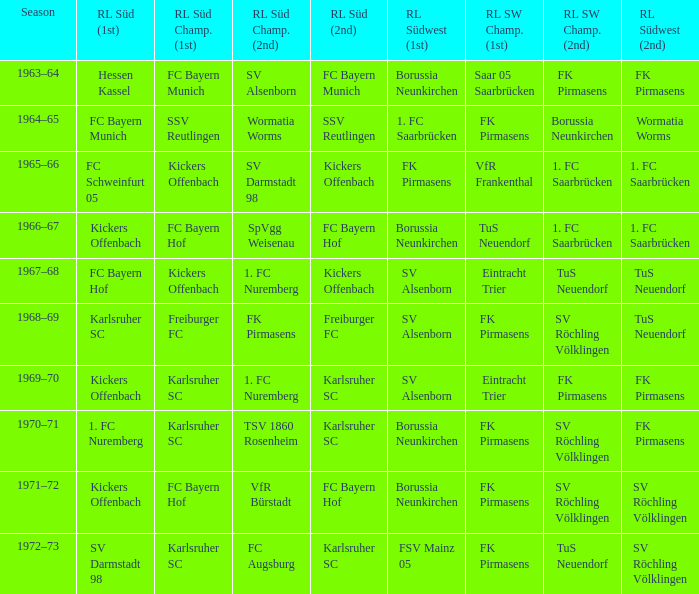Who was RL Süd (1st) when FK Pirmasens was RL Südwest (1st)? FC Schweinfurt 05. 